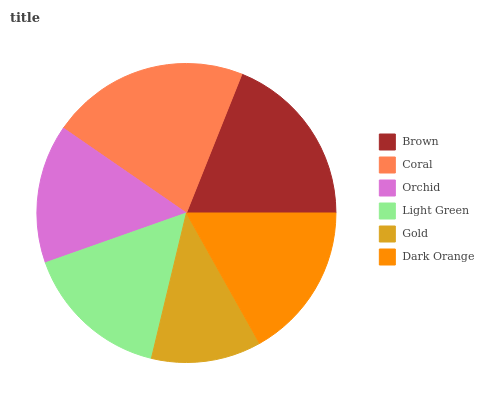Is Gold the minimum?
Answer yes or no. Yes. Is Coral the maximum?
Answer yes or no. Yes. Is Orchid the minimum?
Answer yes or no. No. Is Orchid the maximum?
Answer yes or no. No. Is Coral greater than Orchid?
Answer yes or no. Yes. Is Orchid less than Coral?
Answer yes or no. Yes. Is Orchid greater than Coral?
Answer yes or no. No. Is Coral less than Orchid?
Answer yes or no. No. Is Dark Orange the high median?
Answer yes or no. Yes. Is Light Green the low median?
Answer yes or no. Yes. Is Coral the high median?
Answer yes or no. No. Is Gold the low median?
Answer yes or no. No. 